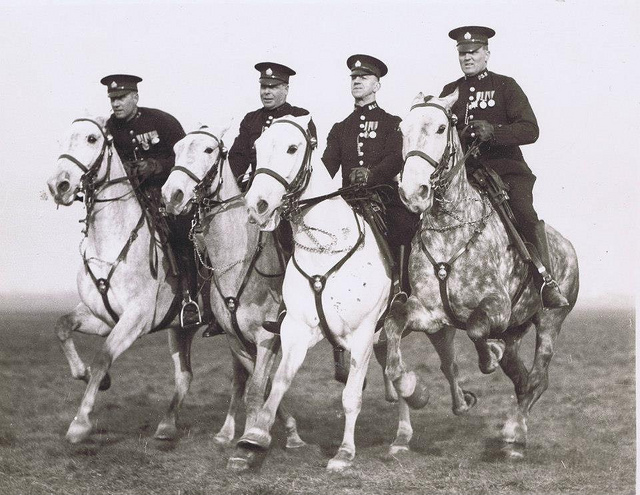<image>Who are riding the horses? It's ambiguous who are riding the horses. It could be either police officers or soldiers. Who are riding the horses? I don't know who are riding the horses. It can be seen police officers, soldiers or officials. 